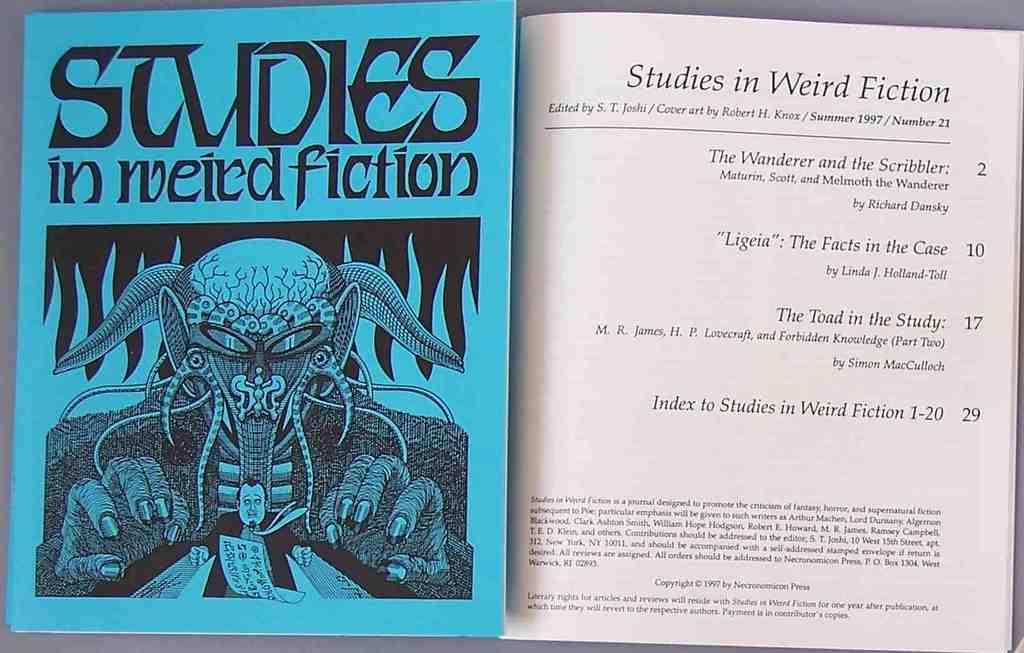What object is present on the left side of the image? There is a book in the image. Can you describe the book's appearance? The book is in the shape of a human and is blue in color. What is the book's primary function? The book's primary function is to be read, although its unique shape may also make it a decorative item. How does the book contribute to reducing pollution in the image? The book does not contribute to reducing pollution in the image, as it is an inanimate object and pollution is not mentioned in the provided facts. 